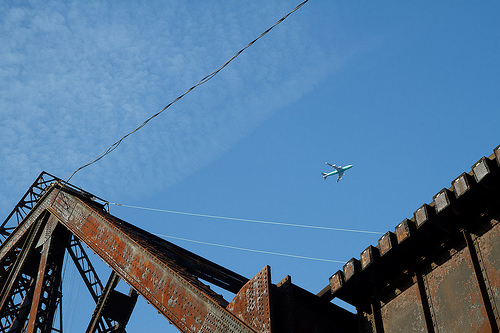Please provide the bounding box coordinate of the region this sentence describes: white clouds in blue sky. [0.36, 0.34, 0.41, 0.42] - This area contains some scattered white clouds against a vibrant blue sky. 